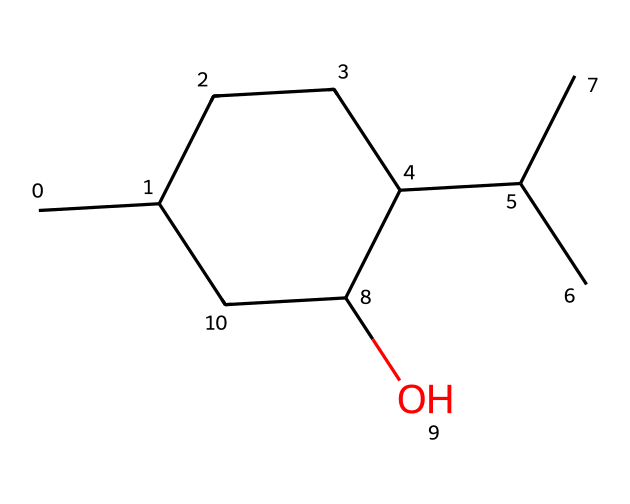What is the molecular formula of this menthol structure? To find the molecular formula, count the number of carbon (C), hydrogen (H), and oxygen (O) atoms in the structure. In this case, there are 10 carbon atoms, 20 hydrogen atoms, and 1 oxygen atom, leading to the formula C10H20O.
Answer: C10H20O How many carbon atoms are present in the cycloalkane structure? By examining the cyclic part of the SMILES representation, we can identify that there are 10 carbon atoms interconnected, as indicated by the notation and the branching shown in the structure.
Answer: 10 What type of functional group is present in this molecule? The presence of the -OH group in the structure identifies it as an alcohol functional group. In the SMILES, this is indicated by the "C(O)" part that shows the carbon bonded to the hydroxyl group.
Answer: alcohol Is this compound saturated or unsaturated? The molecule has no double or triple bonds present between the carbon atoms as indicated in the SMILES. It is fully saturated with hydrogen atoms, hence it can be classified as a saturated compound.
Answer: saturated How many rings are in this structure? The SMILES notation shows a single cycle/composed of carbon atoms indicated by "C1CCC", indicating that there is one cyclic structure in this molecule.
Answer: 1 What is the significance of the hydroxyl group in this cycloalkane? The hydroxyl group (-OH) affects the solubility and taste of the menthol compound, contributing to its cooling sensation in throat lozenges, which is important for flavor in products liked by rappers.
Answer: cooling sensation 